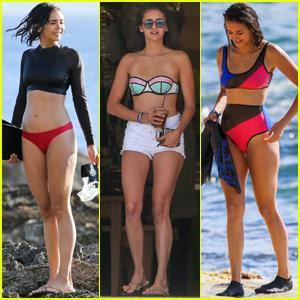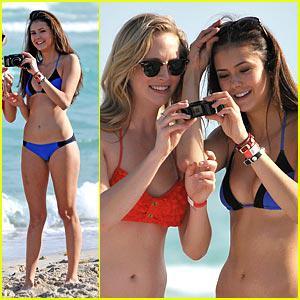The first image is the image on the left, the second image is the image on the right. Evaluate the accuracy of this statement regarding the images: "There are two women wearing swimsuits in the image on the left.". Is it true? Answer yes or no. No. The first image is the image on the left, the second image is the image on the right. Evaluate the accuracy of this statement regarding the images: "The right image shows a woman in a red bikini top and a woman in a blue bikini top looking at a camera together". Is it true? Answer yes or no. Yes. 